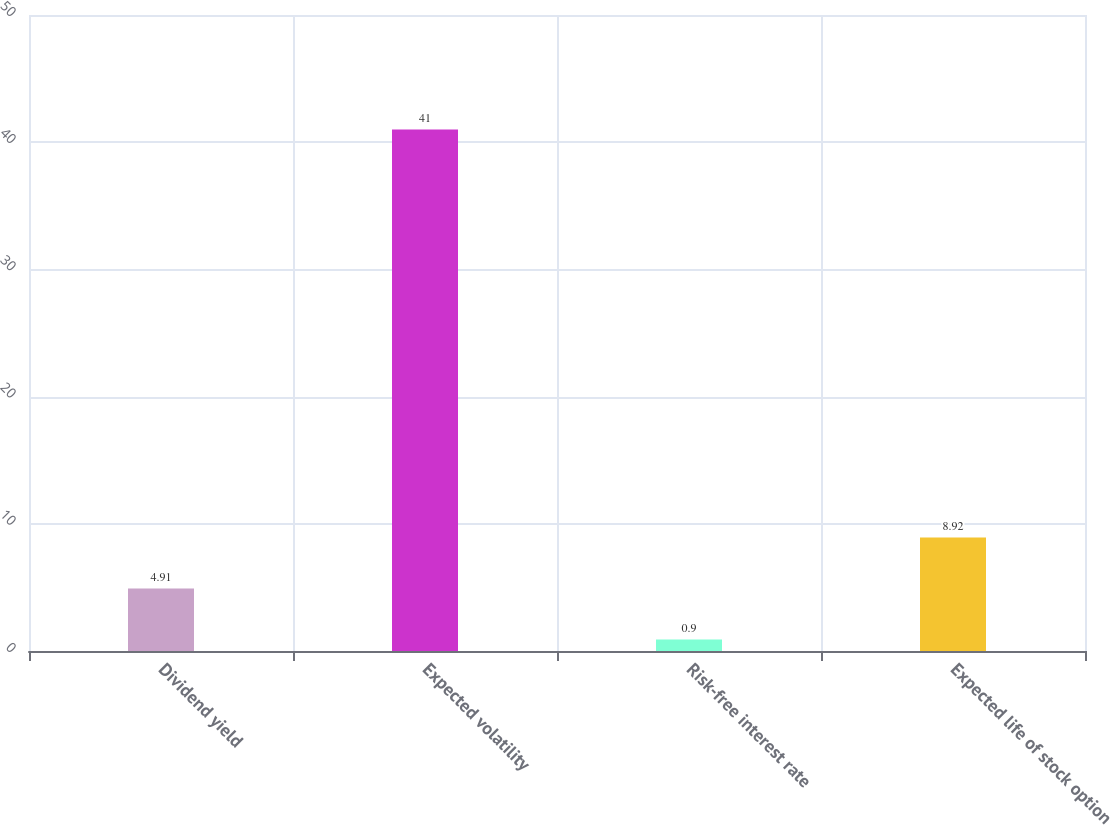Convert chart to OTSL. <chart><loc_0><loc_0><loc_500><loc_500><bar_chart><fcel>Dividend yield<fcel>Expected volatility<fcel>Risk-free interest rate<fcel>Expected life of stock option<nl><fcel>4.91<fcel>41<fcel>0.9<fcel>8.92<nl></chart> 